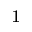<formula> <loc_0><loc_0><loc_500><loc_500>^ { 1 }</formula> 